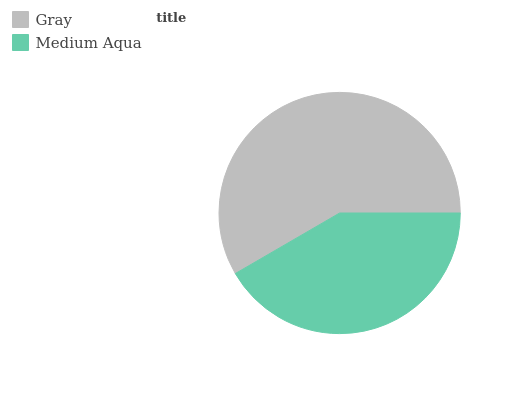Is Medium Aqua the minimum?
Answer yes or no. Yes. Is Gray the maximum?
Answer yes or no. Yes. Is Medium Aqua the maximum?
Answer yes or no. No. Is Gray greater than Medium Aqua?
Answer yes or no. Yes. Is Medium Aqua less than Gray?
Answer yes or no. Yes. Is Medium Aqua greater than Gray?
Answer yes or no. No. Is Gray less than Medium Aqua?
Answer yes or no. No. Is Gray the high median?
Answer yes or no. Yes. Is Medium Aqua the low median?
Answer yes or no. Yes. Is Medium Aqua the high median?
Answer yes or no. No. Is Gray the low median?
Answer yes or no. No. 